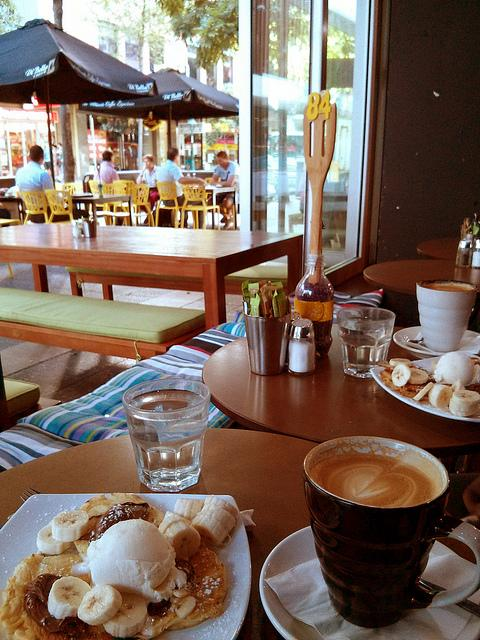What does the number 84 represent?

Choices:
A) table number
B) store number
C) order number
D) price order number 